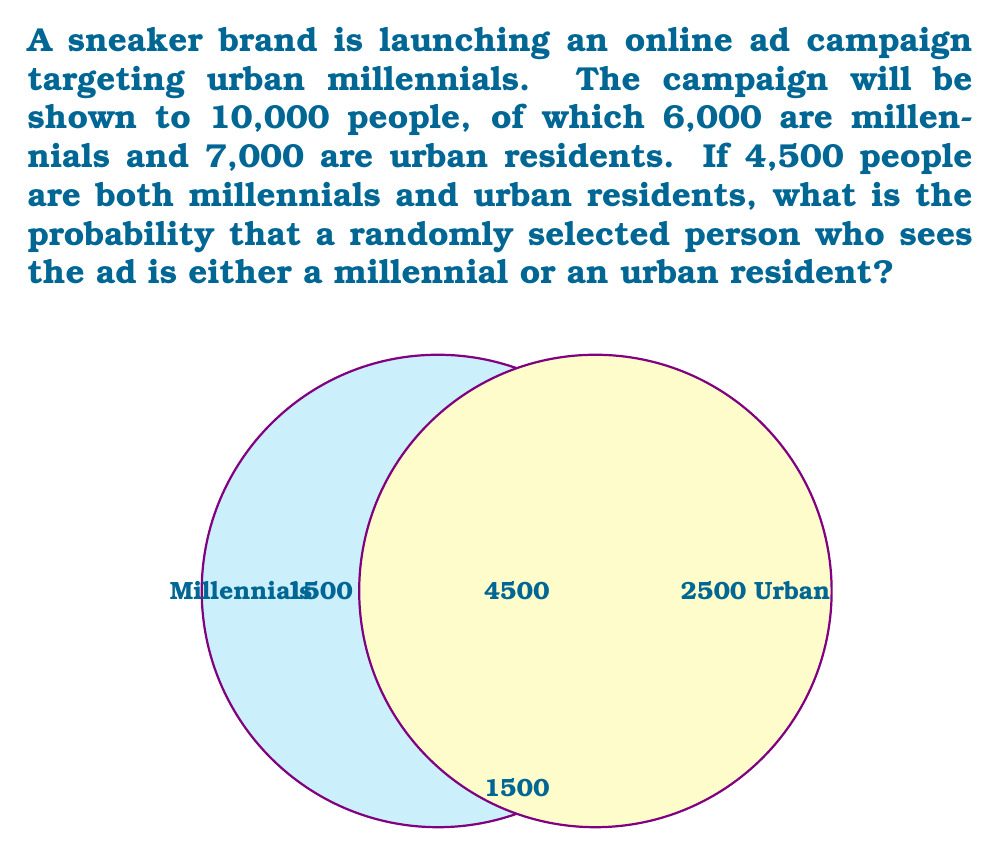Provide a solution to this math problem. Let's approach this step-by-step using set theory:

1) Let M be the set of millennials and U be the set of urban residents.

2) We're given:
   $|M| = 6000$
   $|U| = 7000$
   $|M \cap U| = 4500$
   Total population = 10000

3) We need to find $P(M \cup U)$, the probability of being either a millennial or an urban resident.

4) Using the inclusion-exclusion principle:
   $|M \cup U| = |M| + |U| - |M \cap U|$

5) Substituting the values:
   $|M \cup U| = 6000 + 7000 - 4500 = 8500$

6) The probability is then:
   $$P(M \cup U) = \frac{|M \cup U|}{\text{Total population}} = \frac{8500}{10000} = 0.85$$

Therefore, the probability that a randomly selected person who sees the ad is either a millennial or an urban resident is 0.85 or 85%.
Answer: 0.85 